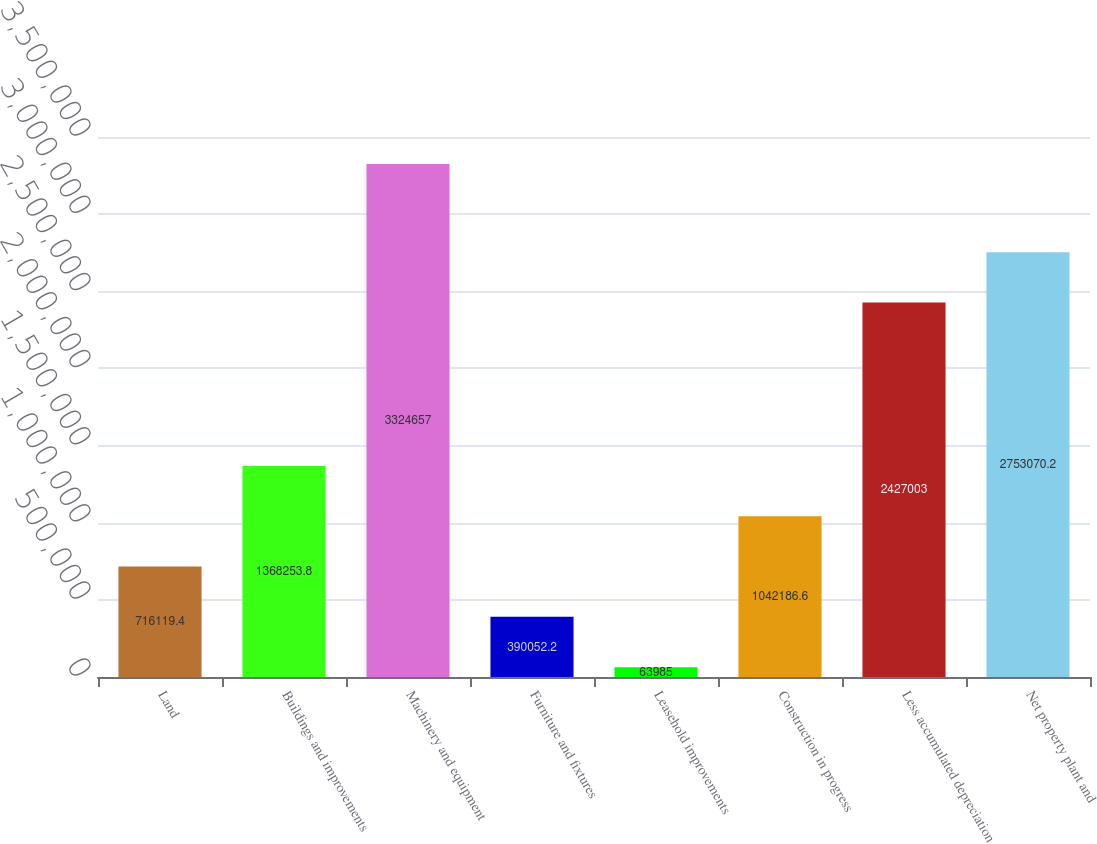<chart> <loc_0><loc_0><loc_500><loc_500><bar_chart><fcel>Land<fcel>Buildings and improvements<fcel>Machinery and equipment<fcel>Furniture and fixtures<fcel>Leasehold improvements<fcel>Construction in progress<fcel>Less accumulated depreciation<fcel>Net property plant and<nl><fcel>716119<fcel>1.36825e+06<fcel>3.32466e+06<fcel>390052<fcel>63985<fcel>1.04219e+06<fcel>2.427e+06<fcel>2.75307e+06<nl></chart> 